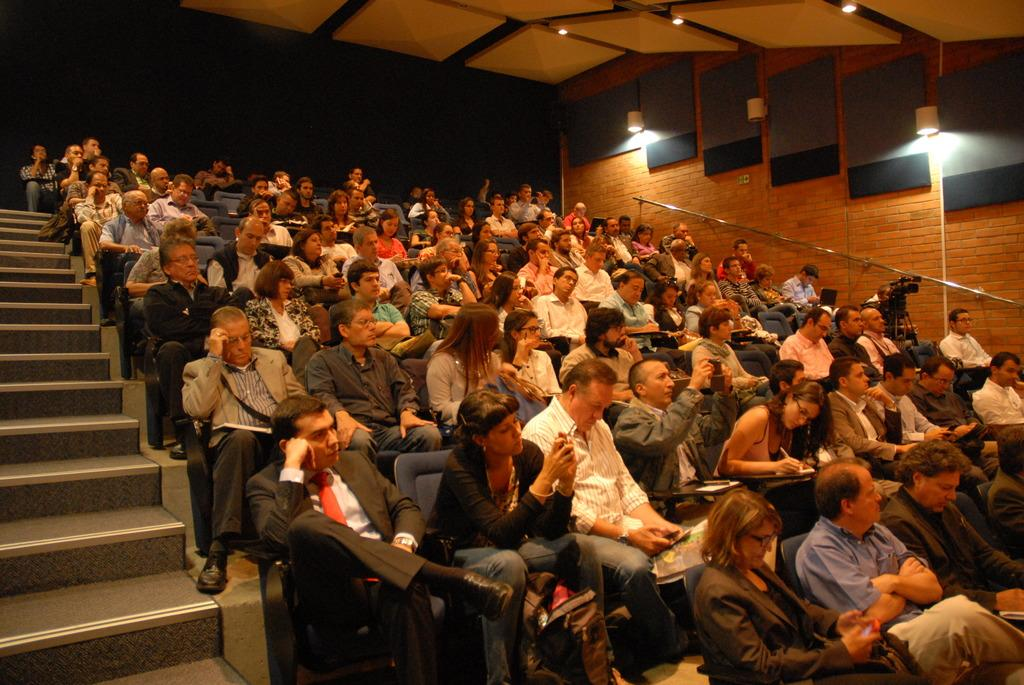How many people are in the image? There is a group of people in the image, but the exact number is not specified. What are the people doing in the image? The people are sitting on chairs and holding objects. What can be seen in the background of the image? There are stairs, lights, and a staircase holder in the image. What equipment is used for photography in the image? There is a camera with a tripod stand in the image. What type of riddle can be solved by the people in the image? There is no riddle present in the image, and the people are not engaged in solving any riddles. 